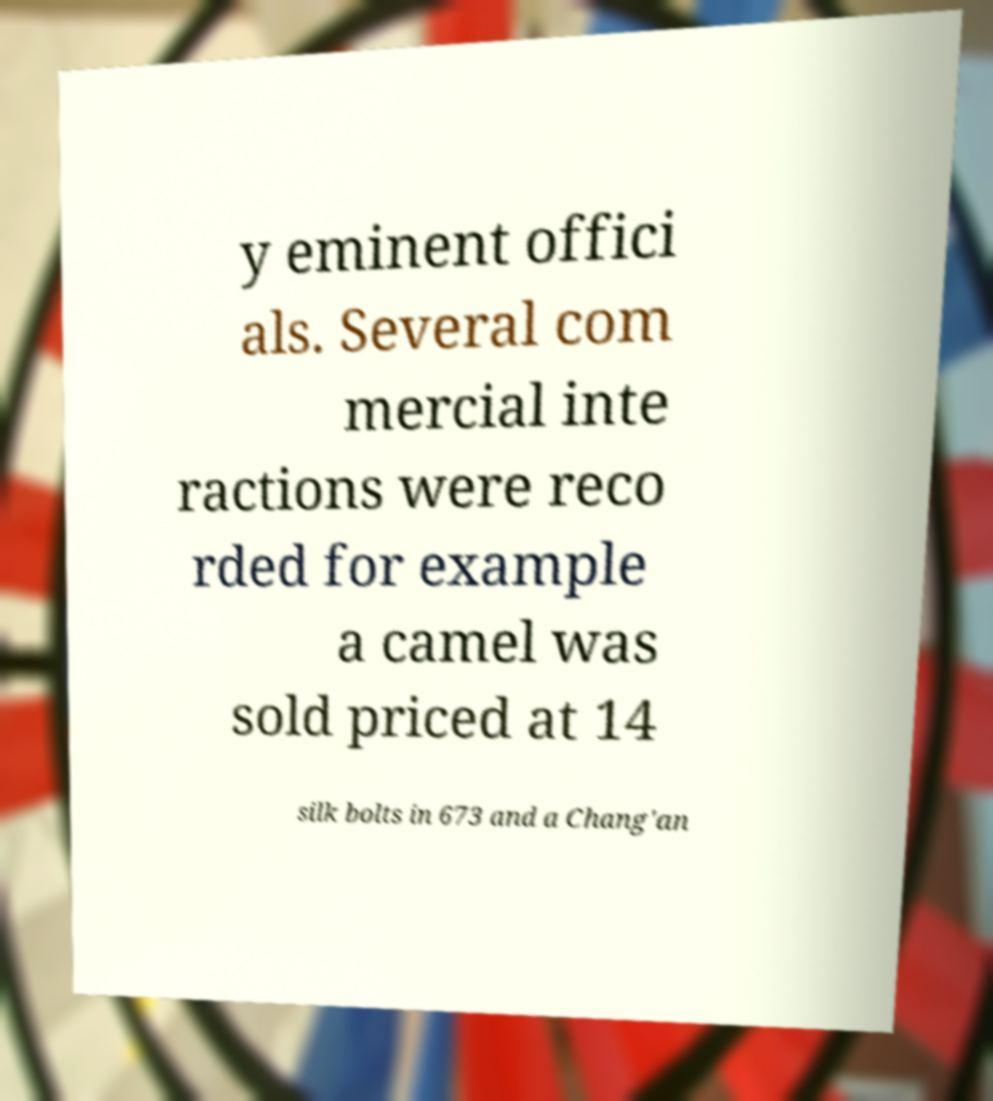For documentation purposes, I need the text within this image transcribed. Could you provide that? y eminent offici als. Several com mercial inte ractions were reco rded for example a camel was sold priced at 14 silk bolts in 673 and a Chang'an 